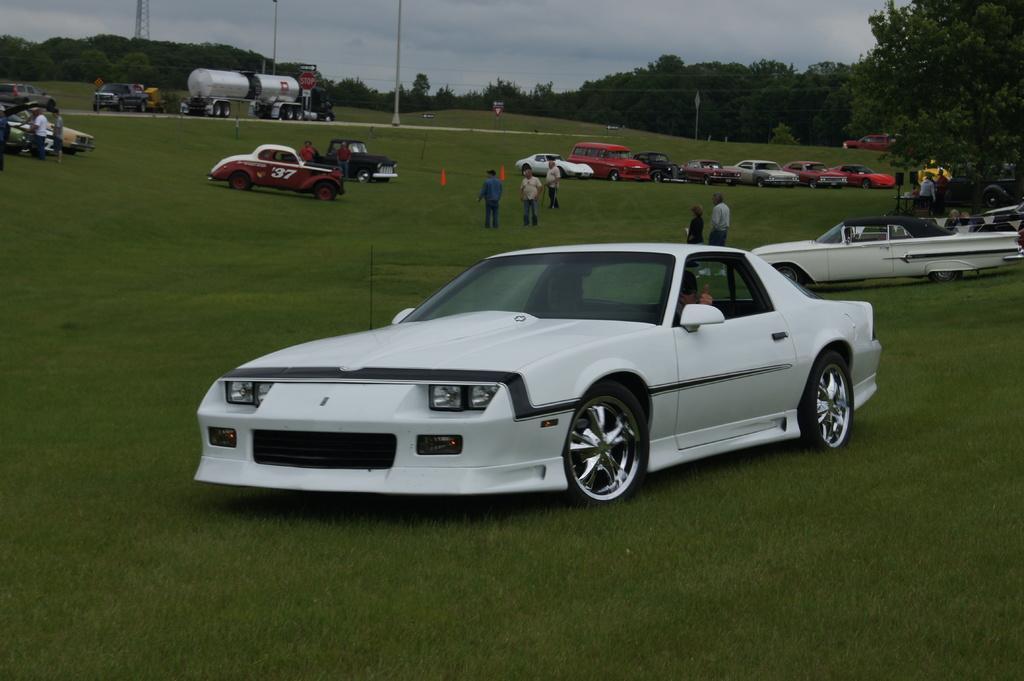Please provide a concise description of this image. In this image we can see the people standing and there are vehicles on the ground. And there are trees, poles, board, tower and the sky. 